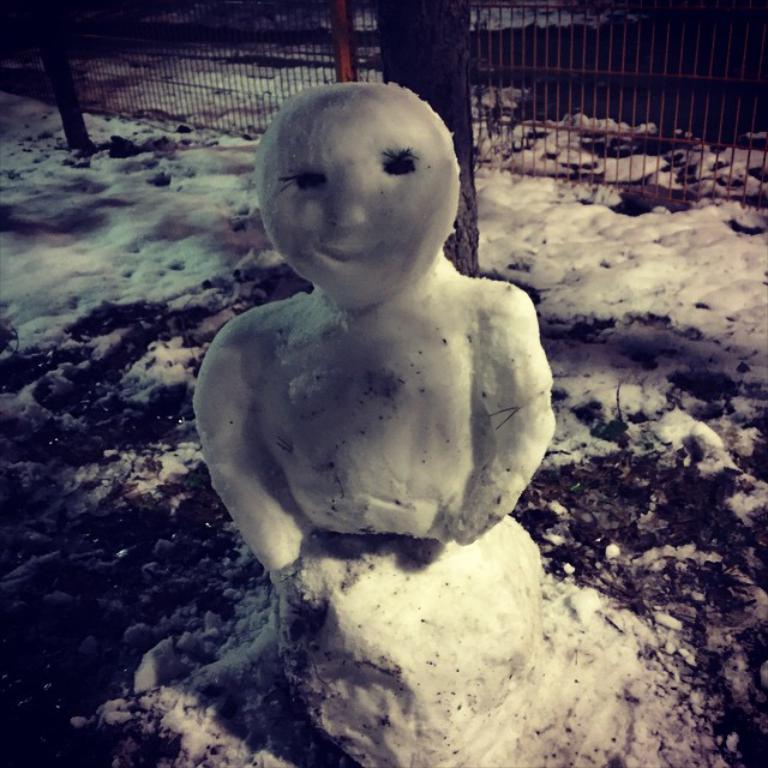Could you give a brief overview of what you see in this image? In this image I can see the statue of the person which is in made up of ice. In the background I can see the tree trunk, railing and also the ice on the ground. 